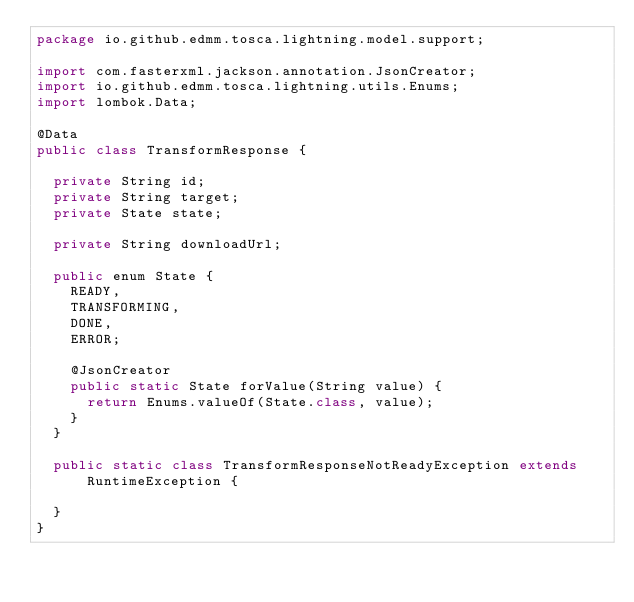Convert code to text. <code><loc_0><loc_0><loc_500><loc_500><_Java_>package io.github.edmm.tosca.lightning.model.support;

import com.fasterxml.jackson.annotation.JsonCreator;
import io.github.edmm.tosca.lightning.utils.Enums;
import lombok.Data;

@Data
public class TransformResponse {

  private String id;
  private String target;
  private State state;

  private String downloadUrl;

  public enum State {
    READY,
    TRANSFORMING,
    DONE,
    ERROR;

    @JsonCreator
    public static State forValue(String value) {
      return Enums.valueOf(State.class, value);
    }
  }

  public static class TransformResponseNotReadyException extends RuntimeException {

  }
}
</code> 